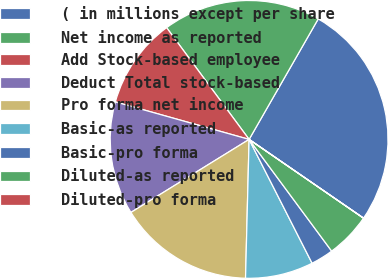<chart> <loc_0><loc_0><loc_500><loc_500><pie_chart><fcel>( in millions except per share<fcel>Net income as reported<fcel>Add Stock-based employee<fcel>Deduct Total stock-based<fcel>Pro forma net income<fcel>Basic-as reported<fcel>Basic-pro forma<fcel>Diluted-as reported<fcel>Diluted-pro forma<nl><fcel>26.3%<fcel>18.41%<fcel>10.53%<fcel>13.16%<fcel>15.78%<fcel>7.9%<fcel>2.64%<fcel>5.27%<fcel>0.01%<nl></chart> 